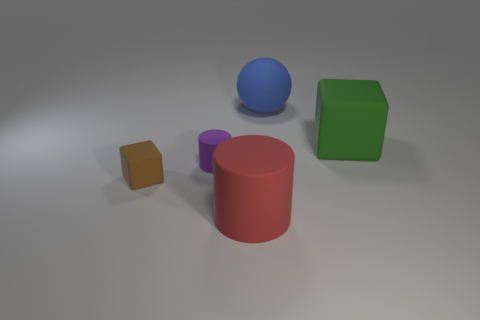There is a rubber cube that is to the left of the cube on the right side of the small rubber cylinder; what is its size?
Ensure brevity in your answer.  Small. Are there any other things that have the same color as the big block?
Provide a succinct answer. No. Is the material of the cube to the left of the red matte cylinder the same as the green cube that is on the right side of the red thing?
Offer a terse response. Yes. What is the big thing that is on the left side of the big green thing and behind the large red rubber object made of?
Provide a short and direct response. Rubber. Does the big red thing have the same shape as the rubber thing that is left of the purple cylinder?
Your response must be concise. No. What is the large thing that is left of the big rubber object behind the block that is right of the big cylinder made of?
Offer a very short reply. Rubber. How many other things are there of the same size as the brown block?
Your answer should be compact. 1. Do the large rubber cube and the tiny rubber cube have the same color?
Your answer should be very brief. No. How many cylinders are to the right of the large object that is in front of the green rubber thing that is on the right side of the large blue matte object?
Make the answer very short. 0. There is a cube right of the big thing that is in front of the green cube; what is it made of?
Offer a very short reply. Rubber. 